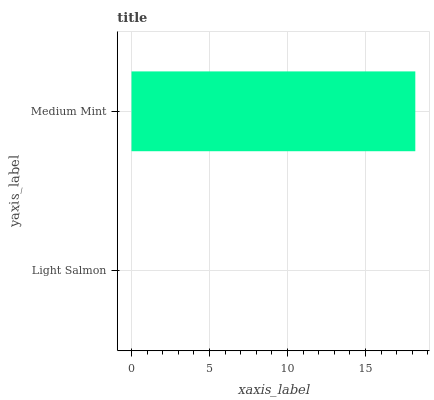Is Light Salmon the minimum?
Answer yes or no. Yes. Is Medium Mint the maximum?
Answer yes or no. Yes. Is Medium Mint the minimum?
Answer yes or no. No. Is Medium Mint greater than Light Salmon?
Answer yes or no. Yes. Is Light Salmon less than Medium Mint?
Answer yes or no. Yes. Is Light Salmon greater than Medium Mint?
Answer yes or no. No. Is Medium Mint less than Light Salmon?
Answer yes or no. No. Is Medium Mint the high median?
Answer yes or no. Yes. Is Light Salmon the low median?
Answer yes or no. Yes. Is Light Salmon the high median?
Answer yes or no. No. Is Medium Mint the low median?
Answer yes or no. No. 